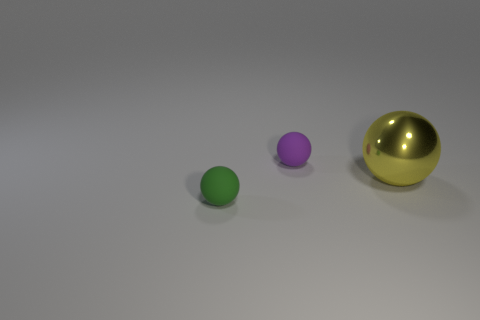There is a small ball on the right side of the tiny green sphere; how many green spheres are in front of it?
Your response must be concise. 1. What number of objects are either matte balls on the right side of the tiny green matte thing or large yellow metallic blocks?
Your response must be concise. 1. Are there any purple objects of the same shape as the large yellow shiny object?
Your response must be concise. Yes. There is a metallic thing that is in front of the small purple matte ball left of the big yellow shiny sphere; what shape is it?
Make the answer very short. Sphere. How many blocks are red matte objects or small green matte things?
Offer a very short reply. 0. Does the small object that is on the right side of the small green thing have the same shape as the tiny object in front of the large sphere?
Provide a succinct answer. Yes. There is a ball that is left of the large yellow metal object and in front of the purple rubber sphere; what color is it?
Provide a succinct answer. Green. What is the size of the thing that is both to the right of the green rubber thing and in front of the small purple ball?
Your response must be concise. Large. What size is the object in front of the sphere right of the rubber ball that is behind the metal ball?
Your response must be concise. Small. Are there any small objects behind the tiny green sphere?
Give a very brief answer. Yes. 